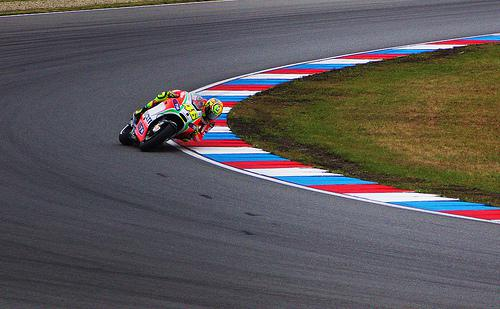Question: what sport is represented in the image?
Choices:
A. Motocross.
B. Basketball.
C. Football.
D. Wrestling.
Answer with the letter. Answer: A Question: where was this image taken?
Choices:
A. At home.
B. The zoo.
C. At a track.
D. Baseball stadium.
Answer with the letter. Answer: C Question: what color is the grass?
Choices:
A. Blue.
B. Green.
C. Brown.
D. Yellow.
Answer with the letter. Answer: B Question: what three colors make up the curb?
Choices:
A. Yellow, green, and black.
B. Neon blue, pink, and purple.
C. Red, yellow, and green.
D. Red, white and blue.
Answer with the letter. Answer: D Question: what color is the track?
Choices:
A. Brown.
B. Black.
C. Grey.
D. Red.
Answer with the letter. Answer: B Question: how many people are watching the rider?
Choices:
A. 0.
B. 1.
C. 2.
D. 10.
Answer with the letter. Answer: A Question: when was this image taken?
Choices:
A. Afternoon.
B. Daytime.
C. Morning.
D. After dinner.
Answer with the letter. Answer: B 